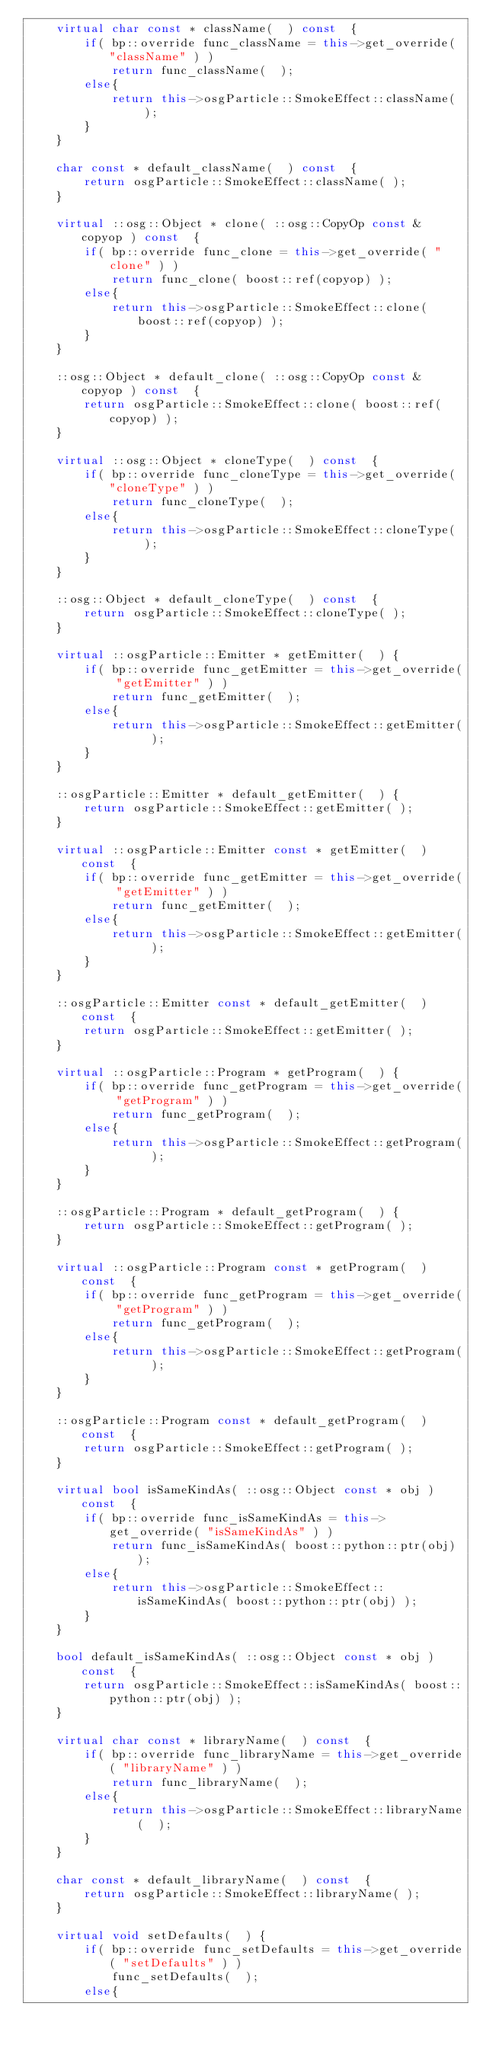Convert code to text. <code><loc_0><loc_0><loc_500><loc_500><_C++_>    virtual char const * className(  ) const  {
        if( bp::override func_className = this->get_override( "className" ) )
            return func_className(  );
        else{
            return this->osgParticle::SmokeEffect::className(  );
        }
    }
    
    char const * default_className(  ) const  {
        return osgParticle::SmokeEffect::className( );
    }

    virtual ::osg::Object * clone( ::osg::CopyOp const & copyop ) const  {
        if( bp::override func_clone = this->get_override( "clone" ) )
            return func_clone( boost::ref(copyop) );
        else{
            return this->osgParticle::SmokeEffect::clone( boost::ref(copyop) );
        }
    }
    
    ::osg::Object * default_clone( ::osg::CopyOp const & copyop ) const  {
        return osgParticle::SmokeEffect::clone( boost::ref(copyop) );
    }

    virtual ::osg::Object * cloneType(  ) const  {
        if( bp::override func_cloneType = this->get_override( "cloneType" ) )
            return func_cloneType(  );
        else{
            return this->osgParticle::SmokeEffect::cloneType(  );
        }
    }
    
    ::osg::Object * default_cloneType(  ) const  {
        return osgParticle::SmokeEffect::cloneType( );
    }

    virtual ::osgParticle::Emitter * getEmitter(  ) {
        if( bp::override func_getEmitter = this->get_override( "getEmitter" ) )
            return func_getEmitter(  );
        else{
            return this->osgParticle::SmokeEffect::getEmitter(  );
        }
    }
    
    ::osgParticle::Emitter * default_getEmitter(  ) {
        return osgParticle::SmokeEffect::getEmitter( );
    }

    virtual ::osgParticle::Emitter const * getEmitter(  ) const  {
        if( bp::override func_getEmitter = this->get_override( "getEmitter" ) )
            return func_getEmitter(  );
        else{
            return this->osgParticle::SmokeEffect::getEmitter(  );
        }
    }
    
    ::osgParticle::Emitter const * default_getEmitter(  ) const  {
        return osgParticle::SmokeEffect::getEmitter( );
    }

    virtual ::osgParticle::Program * getProgram(  ) {
        if( bp::override func_getProgram = this->get_override( "getProgram" ) )
            return func_getProgram(  );
        else{
            return this->osgParticle::SmokeEffect::getProgram(  );
        }
    }
    
    ::osgParticle::Program * default_getProgram(  ) {
        return osgParticle::SmokeEffect::getProgram( );
    }

    virtual ::osgParticle::Program const * getProgram(  ) const  {
        if( bp::override func_getProgram = this->get_override( "getProgram" ) )
            return func_getProgram(  );
        else{
            return this->osgParticle::SmokeEffect::getProgram(  );
        }
    }
    
    ::osgParticle::Program const * default_getProgram(  ) const  {
        return osgParticle::SmokeEffect::getProgram( );
    }

    virtual bool isSameKindAs( ::osg::Object const * obj ) const  {
        if( bp::override func_isSameKindAs = this->get_override( "isSameKindAs" ) )
            return func_isSameKindAs( boost::python::ptr(obj) );
        else{
            return this->osgParticle::SmokeEffect::isSameKindAs( boost::python::ptr(obj) );
        }
    }
    
    bool default_isSameKindAs( ::osg::Object const * obj ) const  {
        return osgParticle::SmokeEffect::isSameKindAs( boost::python::ptr(obj) );
    }

    virtual char const * libraryName(  ) const  {
        if( bp::override func_libraryName = this->get_override( "libraryName" ) )
            return func_libraryName(  );
        else{
            return this->osgParticle::SmokeEffect::libraryName(  );
        }
    }
    
    char const * default_libraryName(  ) const  {
        return osgParticle::SmokeEffect::libraryName( );
    }

    virtual void setDefaults(  ) {
        if( bp::override func_setDefaults = this->get_override( "setDefaults" ) )
            func_setDefaults(  );
        else{</code> 